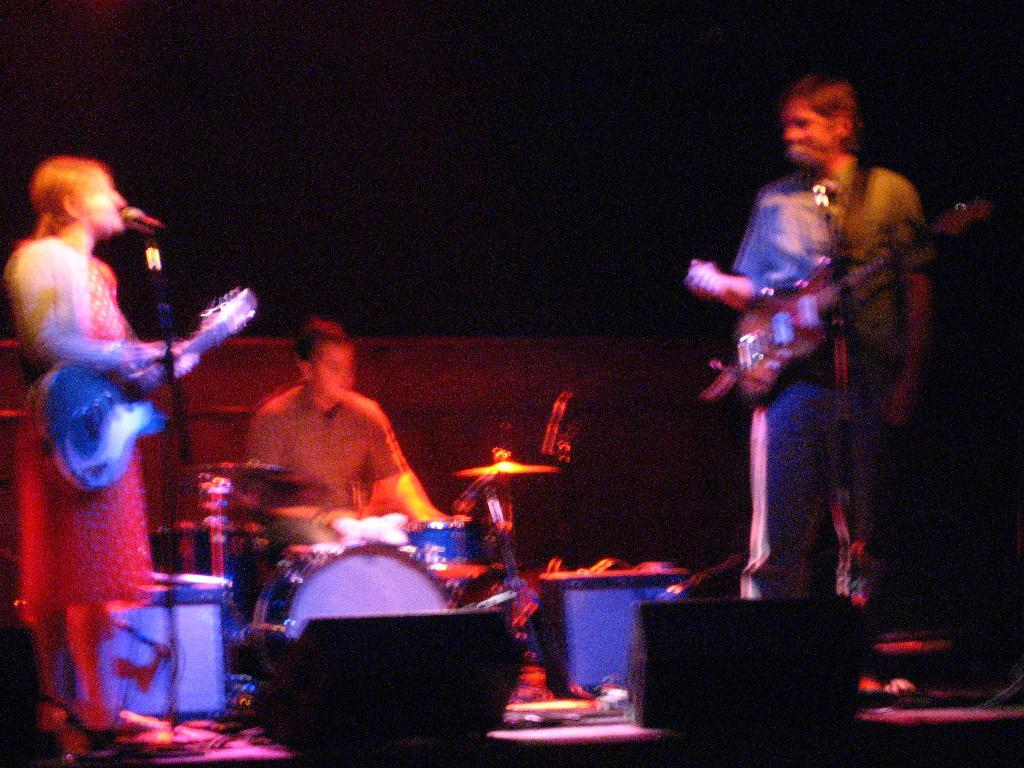How many people are in the image? There are three persons in the image. What are the people doing in the image? One person is playing a guitar, one person is playing drums, and one person is singing on a mic. What is the color of the background in the image? The background of the image is dark. Can you tell me what type of vest the baby is wearing in the image? There is no baby present in the image, so it is not possible to determine what type of vest they might be wearing. 